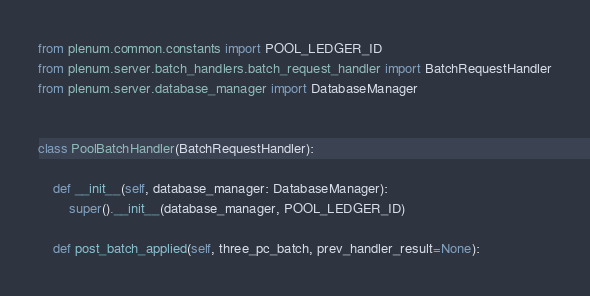Convert code to text. <code><loc_0><loc_0><loc_500><loc_500><_Python_>from plenum.common.constants import POOL_LEDGER_ID
from plenum.server.batch_handlers.batch_request_handler import BatchRequestHandler
from plenum.server.database_manager import DatabaseManager


class PoolBatchHandler(BatchRequestHandler):

    def __init__(self, database_manager: DatabaseManager):
        super().__init__(database_manager, POOL_LEDGER_ID)

    def post_batch_applied(self, three_pc_batch, prev_handler_result=None):</code> 